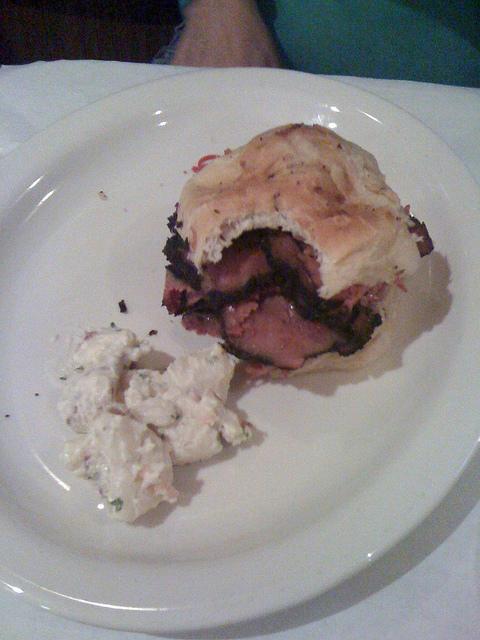Is this affirmation: "The person is surrounding the sandwich." correct?
Answer yes or no. No. Is "The sandwich is touching the person." an appropriate description for the image?
Answer yes or no. No. 